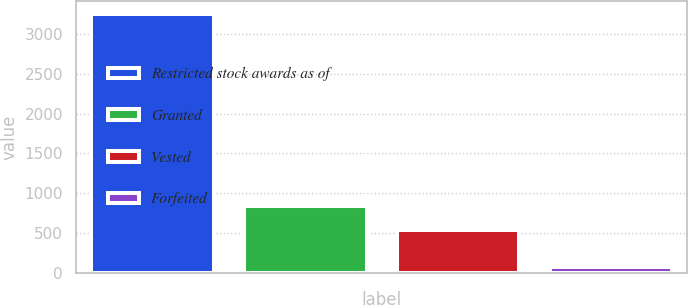Convert chart. <chart><loc_0><loc_0><loc_500><loc_500><bar_chart><fcel>Restricted stock awards as of<fcel>Granted<fcel>Vested<fcel>Forfeited<nl><fcel>3253.2<fcel>842.2<fcel>538<fcel>74<nl></chart> 